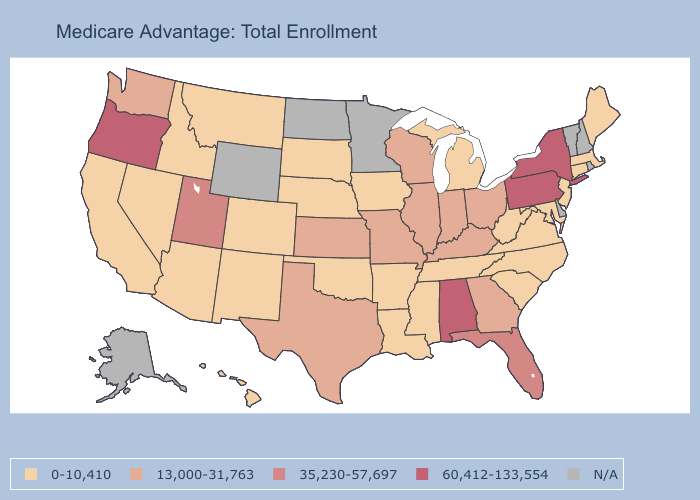Which states have the lowest value in the USA?
Concise answer only. Arkansas, Arizona, California, Colorado, Connecticut, Hawaii, Iowa, Idaho, Louisiana, Massachusetts, Maryland, Maine, Michigan, Mississippi, Montana, North Carolina, Nebraska, New Jersey, New Mexico, Nevada, Oklahoma, South Carolina, South Dakota, Tennessee, Virginia, West Virginia. What is the lowest value in the West?
Give a very brief answer. 0-10,410. What is the highest value in the West ?
Short answer required. 60,412-133,554. What is the value of Alabama?
Write a very short answer. 60,412-133,554. What is the lowest value in the USA?
Quick response, please. 0-10,410. What is the value of South Carolina?
Answer briefly. 0-10,410. Is the legend a continuous bar?
Keep it brief. No. Which states have the lowest value in the Northeast?
Write a very short answer. Connecticut, Massachusetts, Maine, New Jersey. Name the states that have a value in the range 13,000-31,763?
Give a very brief answer. Georgia, Illinois, Indiana, Kansas, Kentucky, Missouri, Ohio, Texas, Washington, Wisconsin. What is the highest value in the USA?
Write a very short answer. 60,412-133,554. What is the value of Minnesota?
Answer briefly. N/A. What is the value of New Jersey?
Quick response, please. 0-10,410. Name the states that have a value in the range N/A?
Answer briefly. Alaska, Delaware, Minnesota, North Dakota, New Hampshire, Rhode Island, Vermont, Wyoming. What is the lowest value in the USA?
Be succinct. 0-10,410. 